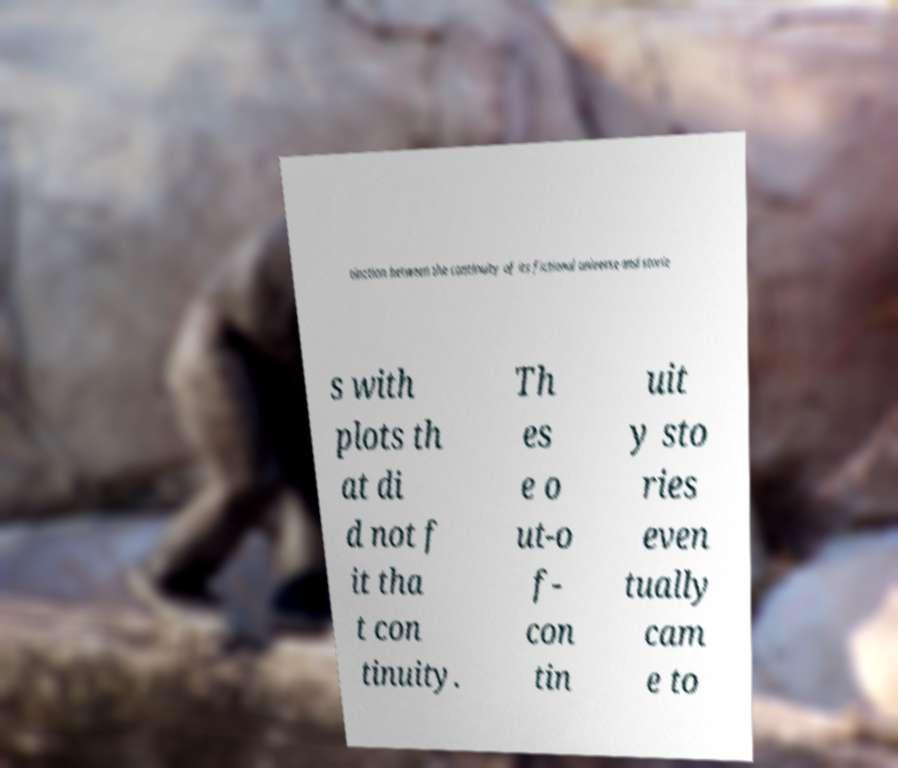Please identify and transcribe the text found in this image. tinction between the continuity of its fictional universe and storie s with plots th at di d not f it tha t con tinuity. Th es e o ut-o f- con tin uit y sto ries even tually cam e to 